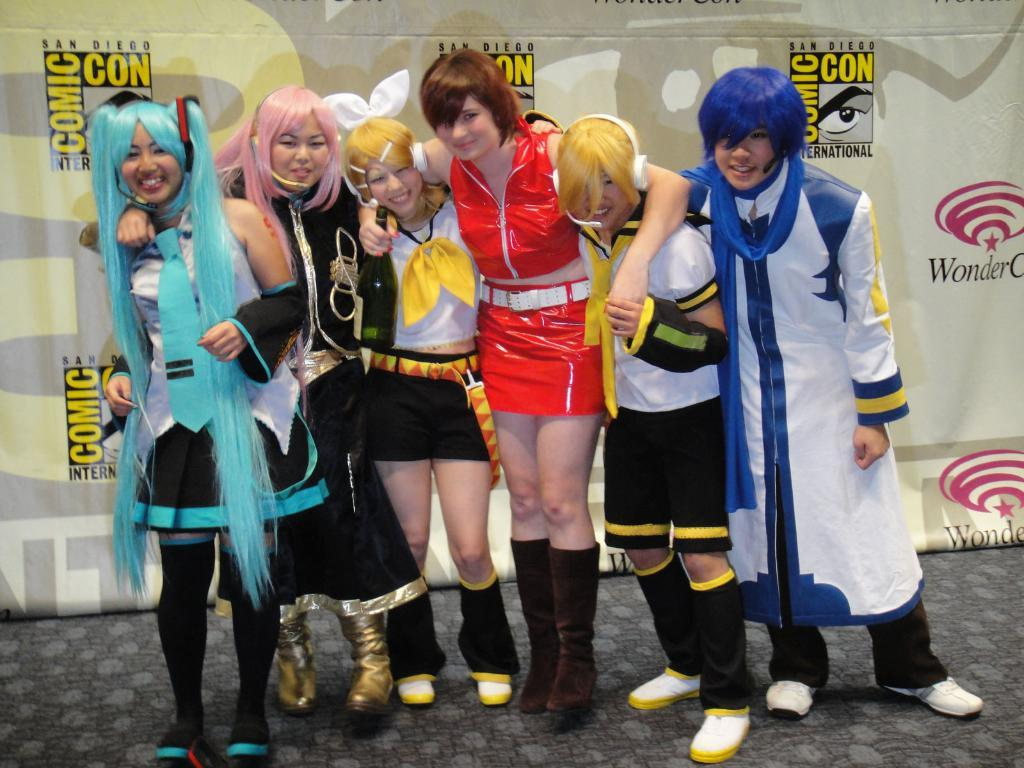Provide a one-sentence caption for the provided image. a comic con ad behind some kids that are posing. 